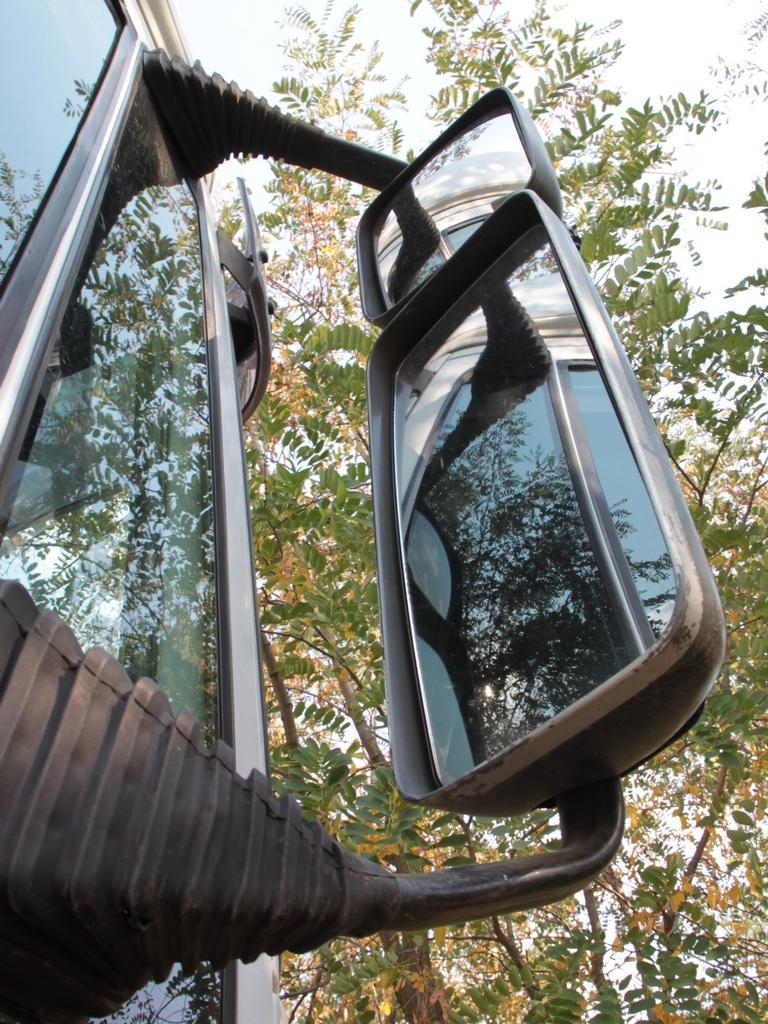Can you describe this image briefly? In the picture I can see mirrors attached to a glass object. In the background I can see trees and the sky. 